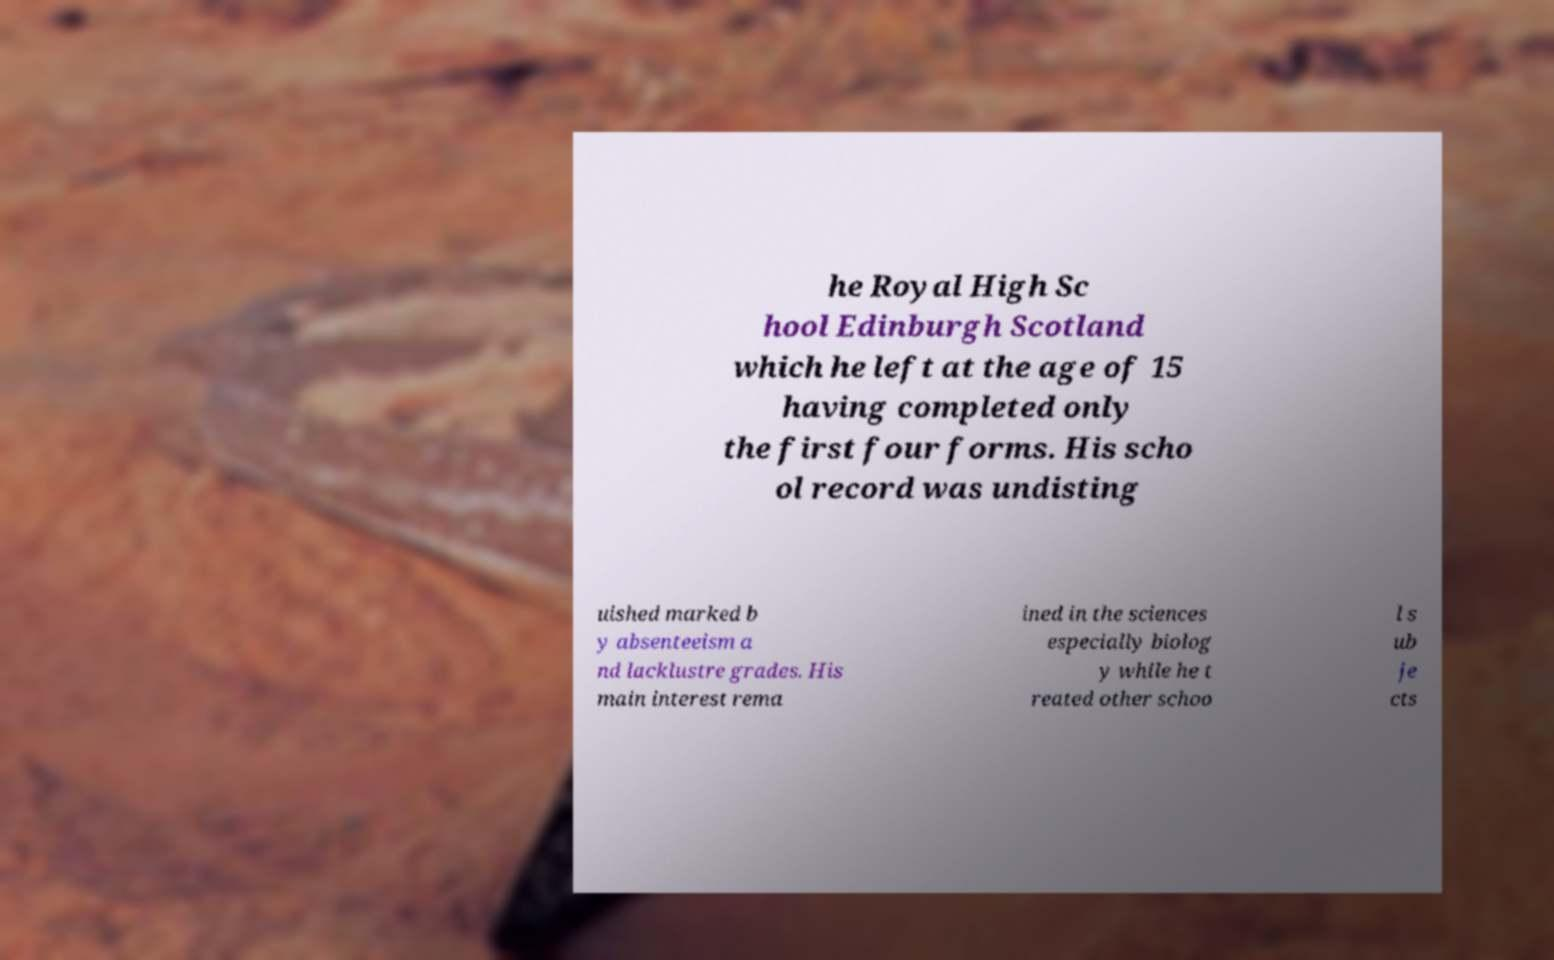Please identify and transcribe the text found in this image. he Royal High Sc hool Edinburgh Scotland which he left at the age of 15 having completed only the first four forms. His scho ol record was undisting uished marked b y absenteeism a nd lacklustre grades. His main interest rema ined in the sciences especially biolog y while he t reated other schoo l s ub je cts 